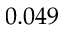Convert formula to latex. <formula><loc_0><loc_0><loc_500><loc_500>0 . 0 4 9</formula> 